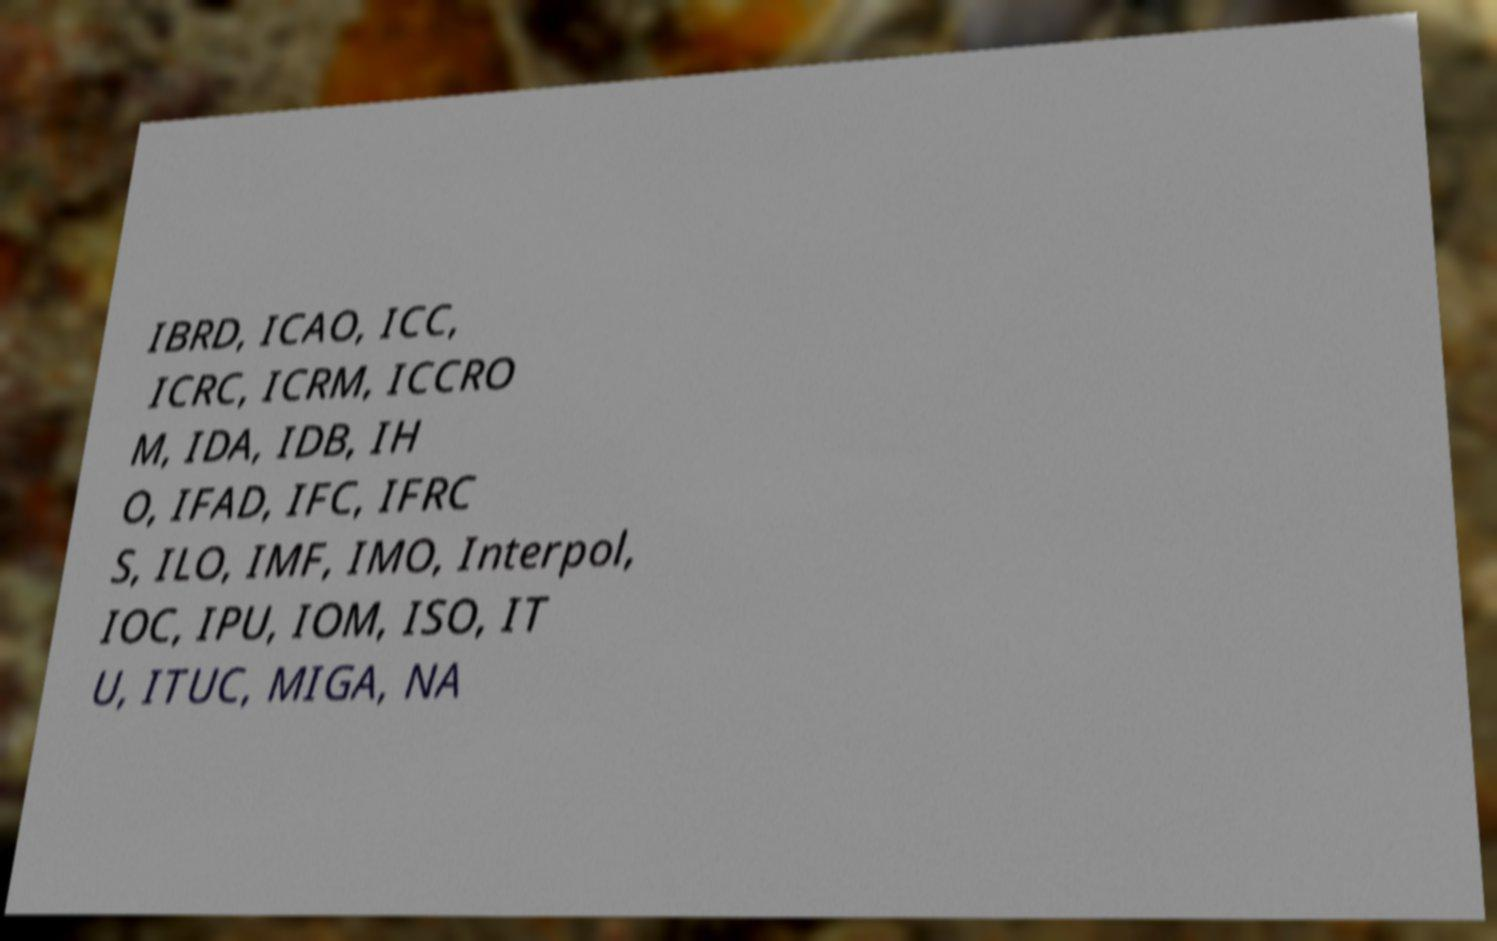There's text embedded in this image that I need extracted. Can you transcribe it verbatim? IBRD, ICAO, ICC, ICRC, ICRM, ICCRO M, IDA, IDB, IH O, IFAD, IFC, IFRC S, ILO, IMF, IMO, Interpol, IOC, IPU, IOM, ISO, IT U, ITUC, MIGA, NA 